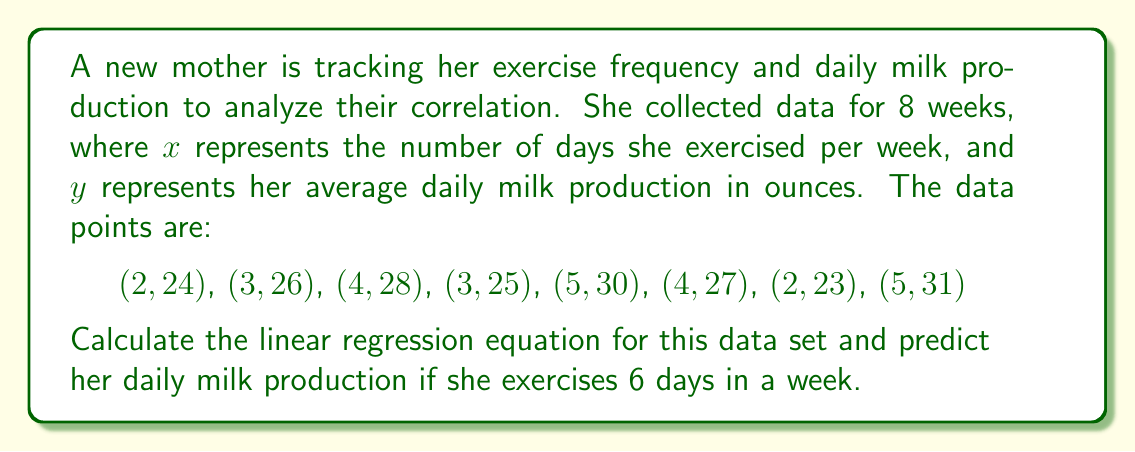Can you solve this math problem? To find the linear regression equation and make a prediction, we'll follow these steps:

1. Calculate the means of $x$ and $y$:
   $\bar{x} = \frac{\sum x}{n} = \frac{28}{8} = 3.5$
   $\bar{y} = \frac{\sum y}{n} = \frac{214}{8} = 26.75$

2. Calculate $\sum (x - \bar{x})(y - \bar{y})$ and $\sum (x - \bar{x})^2$:

   $\sum (x - \bar{x})(y - \bar{y}) = 21.5$
   $\sum (x - \bar{x})^2 = 11.5$

3. Calculate the slope $m$:
   $m = \frac{\sum (x - \bar{x})(y - \bar{y})}{\sum (x - \bar{x})^2} = \frac{21.5}{11.5} \approx 1.87$

4. Calculate the y-intercept $b$:
   $b = \bar{y} - m\bar{x} = 26.75 - 1.87(3.5) \approx 20.21$

5. Form the linear regression equation:
   $y = 1.87x + 20.21$

6. Predict milk production for 6 days of exercise:
   $y = 1.87(6) + 20.21 \approx 31.43$
Answer: The linear regression equation is $y = 1.87x + 20.21$, where $x$ is the number of exercise days per week and $y$ is the predicted daily milk production in ounces. If the mother exercises 6 days in a week, her predicted daily milk production would be approximately 31.43 ounces. 